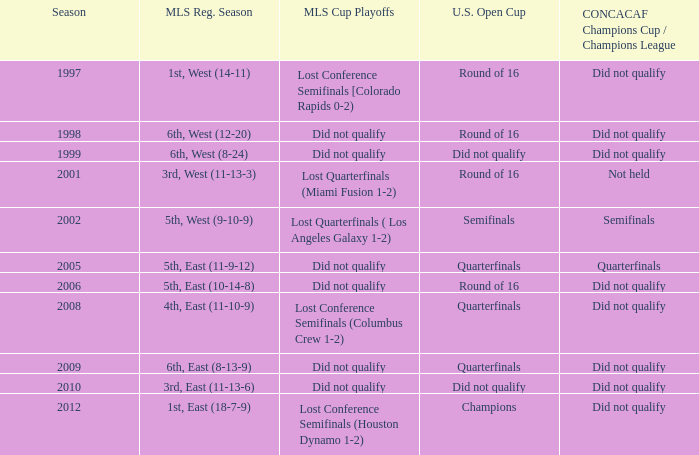When was the first season? 1997.0. 